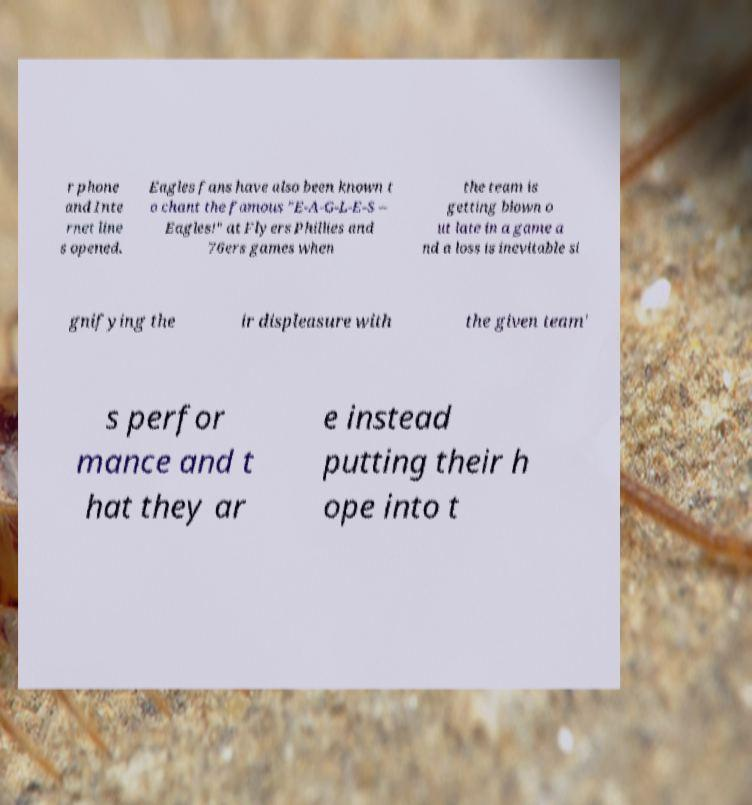Can you accurately transcribe the text from the provided image for me? r phone and Inte rnet line s opened. Eagles fans have also been known t o chant the famous "E-A-G-L-E-S – Eagles!" at Flyers Phillies and 76ers games when the team is getting blown o ut late in a game a nd a loss is inevitable si gnifying the ir displeasure with the given team' s perfor mance and t hat they ar e instead putting their h ope into t 